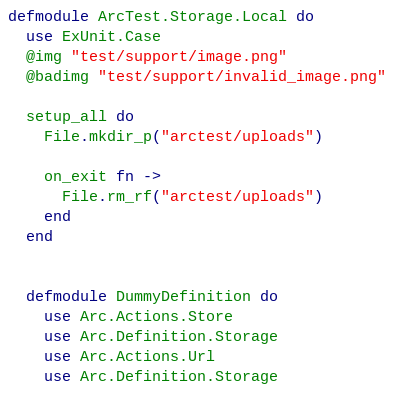Convert code to text. <code><loc_0><loc_0><loc_500><loc_500><_Elixir_>defmodule ArcTest.Storage.Local do
  use ExUnit.Case
  @img "test/support/image.png"
  @badimg "test/support/invalid_image.png"

  setup_all do
    File.mkdir_p("arctest/uploads")

    on_exit fn ->
      File.rm_rf("arctest/uploads")
    end
  end


  defmodule DummyDefinition do
    use Arc.Actions.Store
    use Arc.Definition.Storage
    use Arc.Actions.Url
    use Arc.Definition.Storage
</code> 